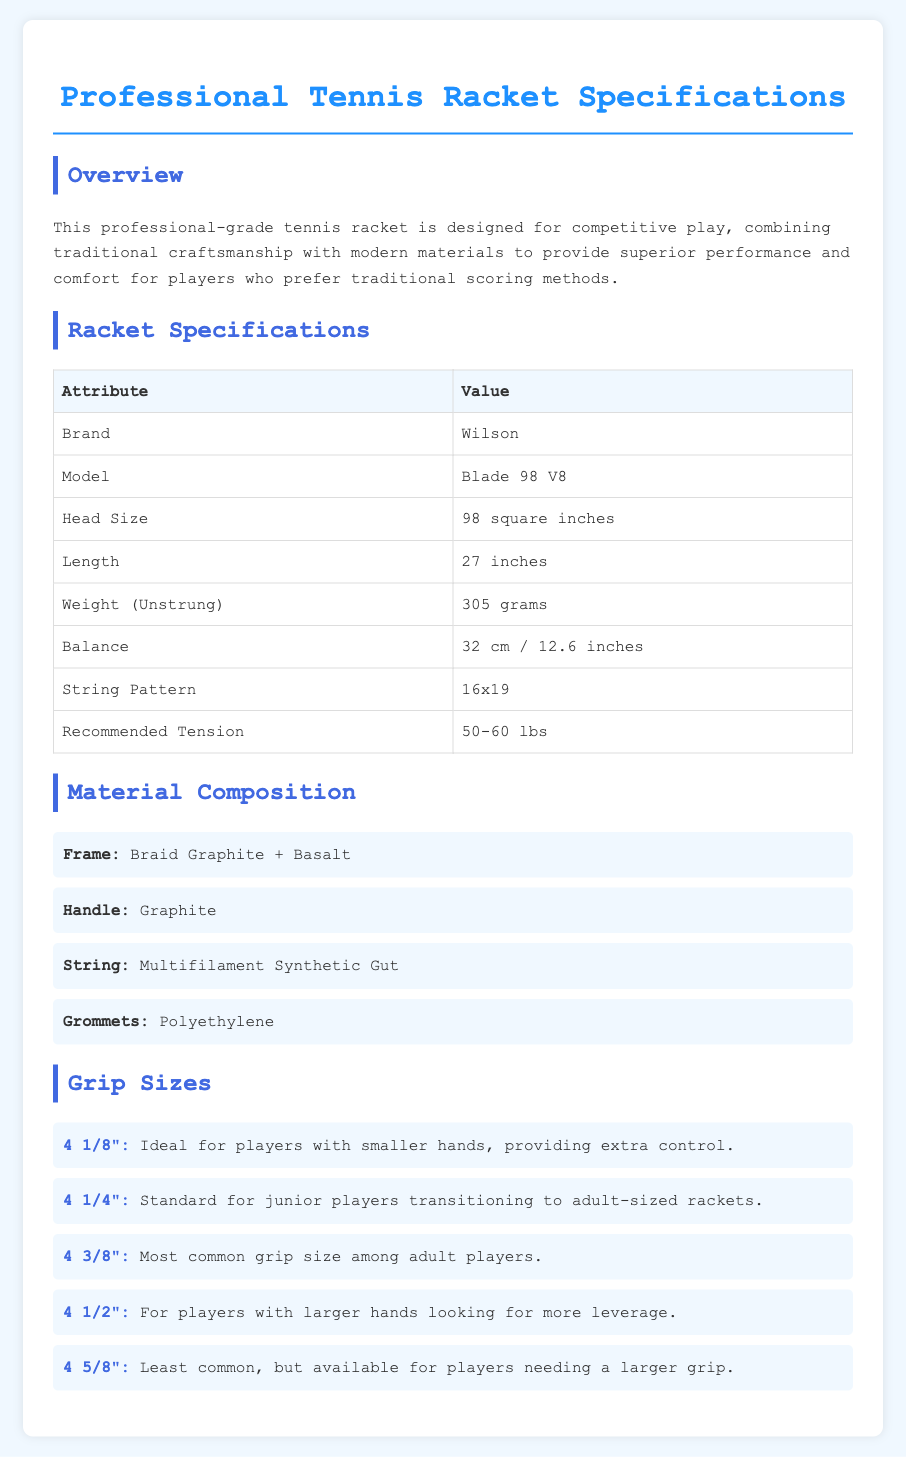What is the brand of the racket? The brand is specified in the Racket Specifications section, under the Attribute "Brand."
Answer: Wilson What is the head size of the racket? The head size is provided in the Racket Specifications section, under the Attribute "Head Size."
Answer: 98 square inches What is the weight of the racket when unstrung? The weight is listed in the Racket Specifications section, under the Attribute "Weight (Unstrung)."
Answer: 305 grams What material is used for the frame? The material for the frame is mentioned in the Material Composition section.
Answer: Braid Graphite + Basalt Which grip size is most common among adult players? The most common grip size is detailed in the Grip Sizes section.
Answer: 4 3/8" What is the recommended tension range for the racket? The recommended tension is specified in the Racket Specifications section, under the Attribute "Recommended Tension."
Answer: 50-60 lbs What is the length of the racket? The length is listed in the Racket Specifications section, under the Attribute "Length."
Answer: 27 inches How many grip size options are listed? The number of grip size options can be counted in the Grip Sizes section.
Answer: 5 Which materials are used for the strings? The material used for strings is stated in the Material Composition section.
Answer: Multifilament Synthetic Gut 